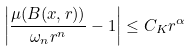Convert formula to latex. <formula><loc_0><loc_0><loc_500><loc_500>\left | \frac { \mu ( B ( x , r ) ) } { \omega _ { n } r ^ { n } } - 1 \right | \leq C _ { K } r ^ { \alpha }</formula> 